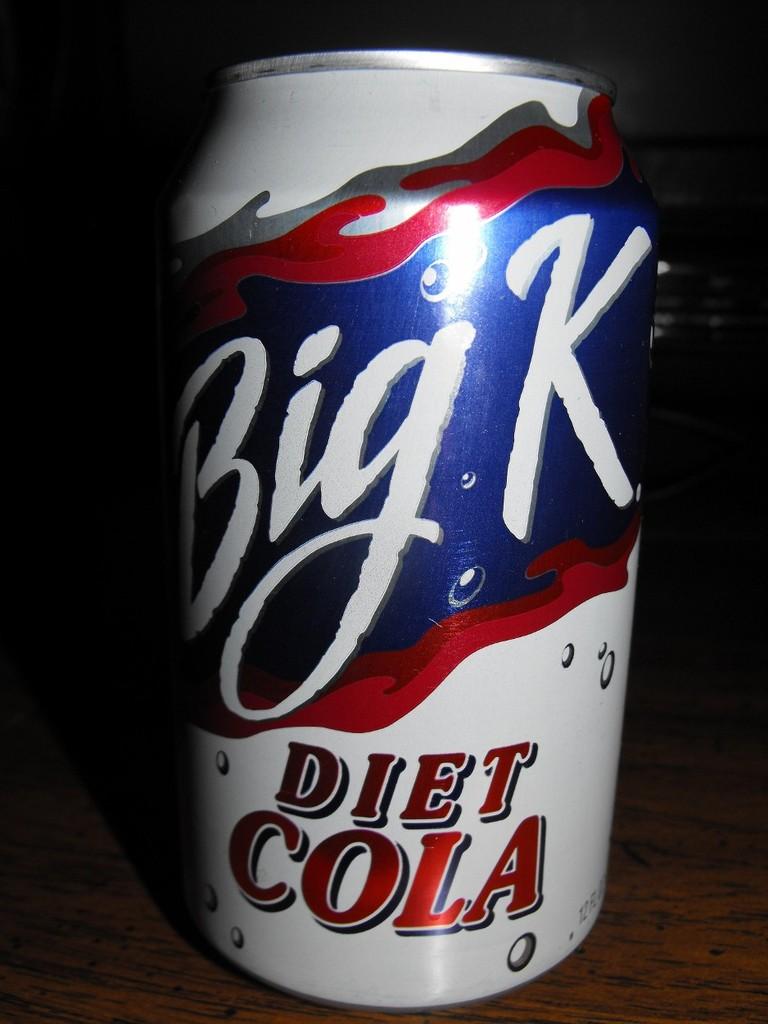Is this a regular soda?
Offer a very short reply. No. What is the brand name?
Keep it short and to the point. Big k. 